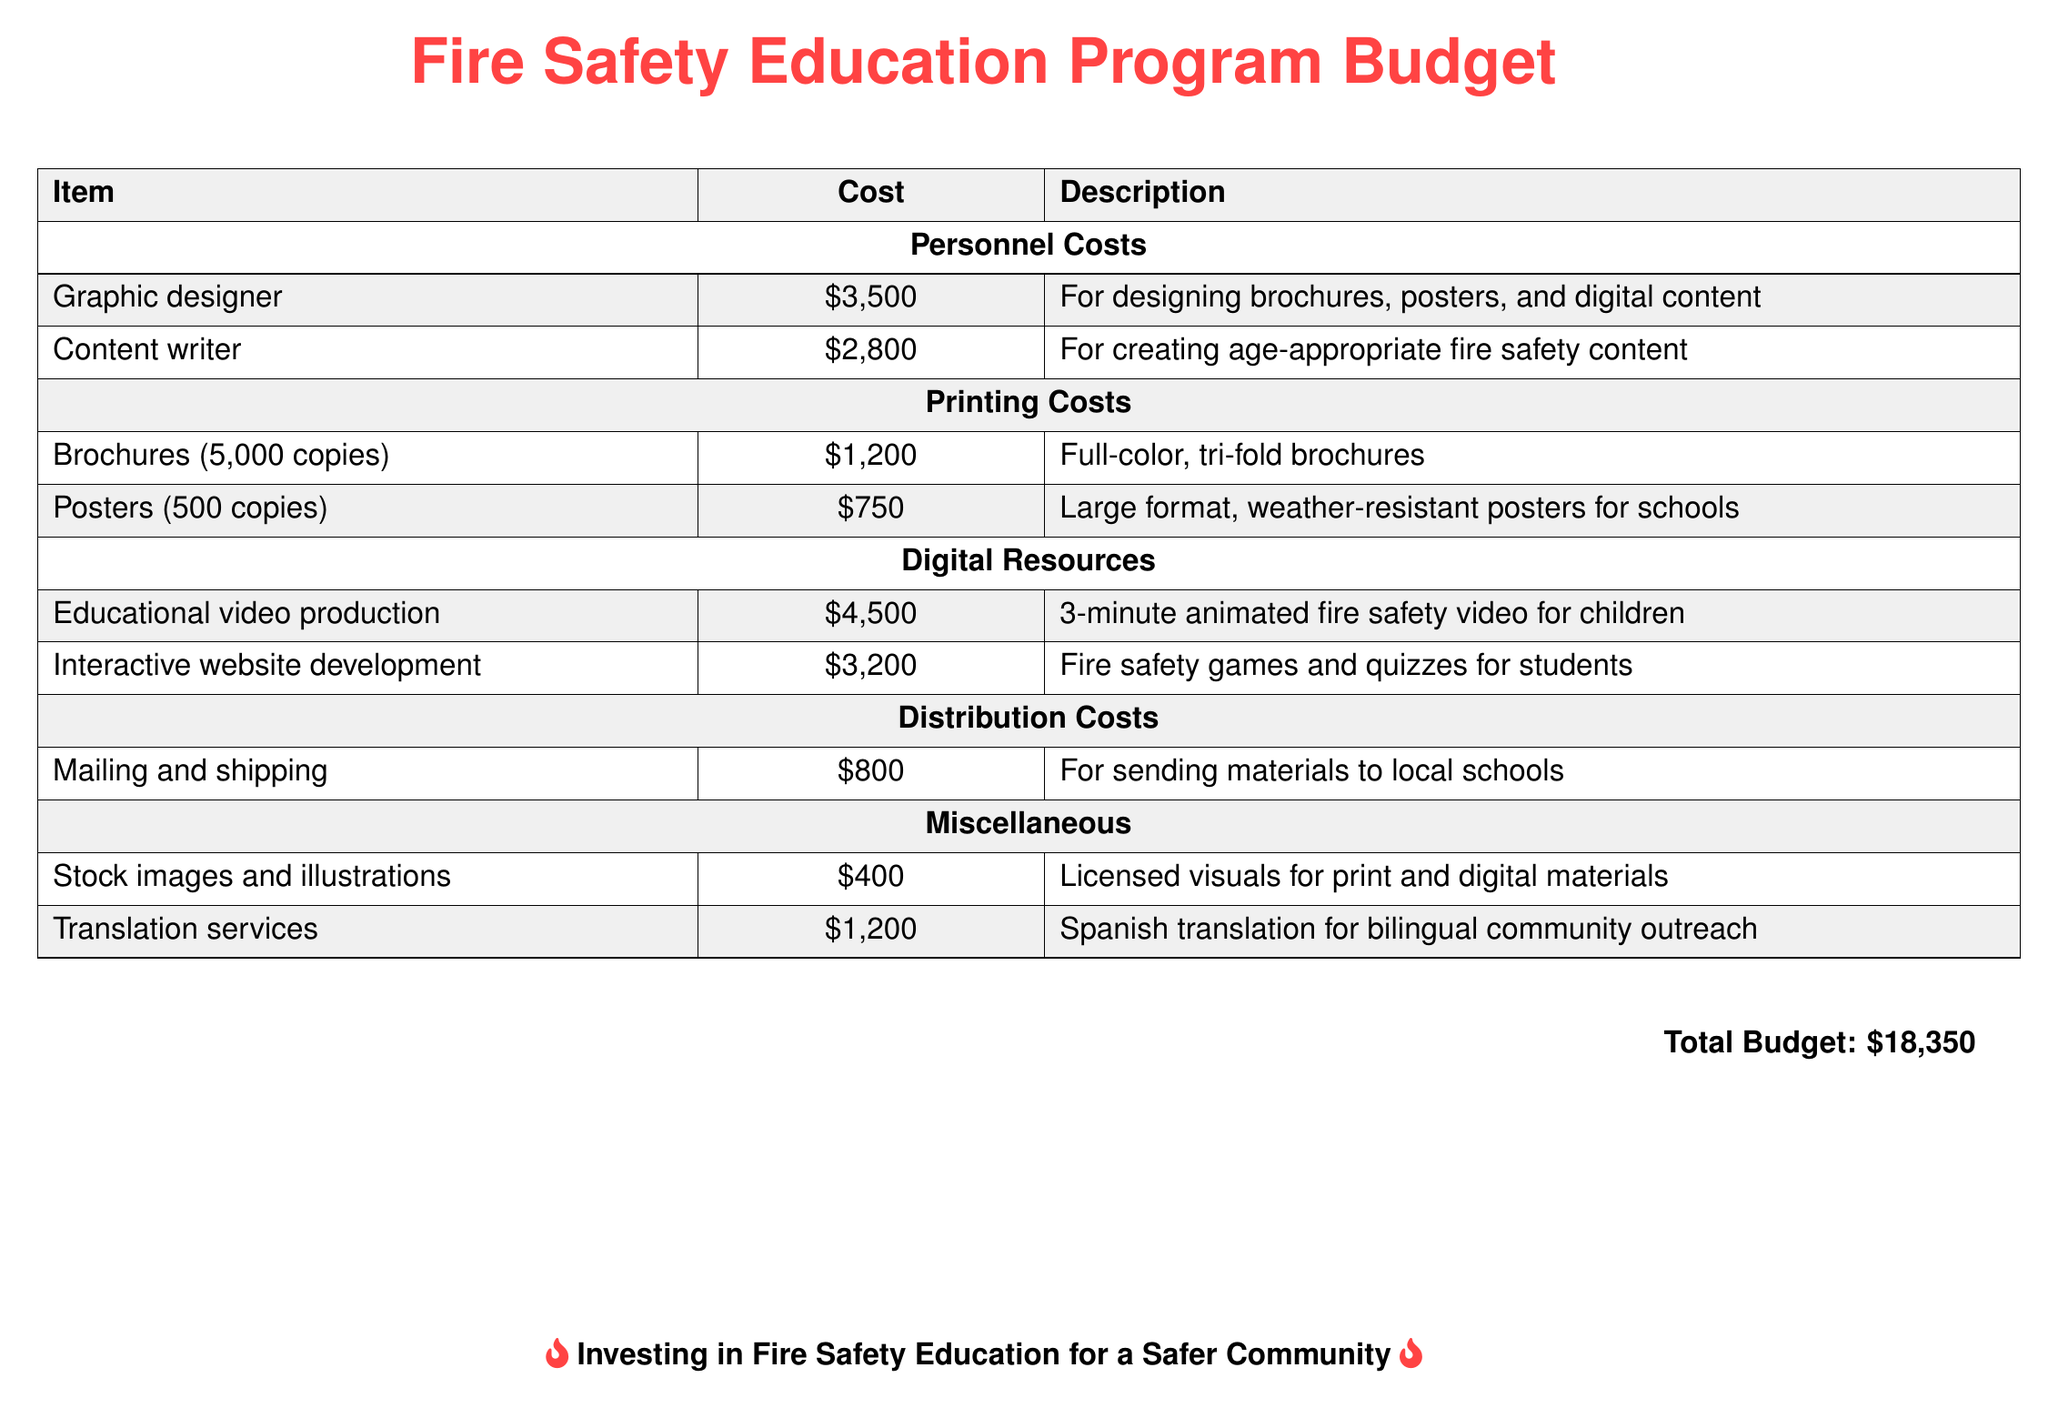What is the total budget? The total budget is found at the bottom of the document, which sums up all costs listed.
Answer: $18,350 How much is allocated for the graphic designer? The budget specifies $3,500 for the graphic designer under personnel costs.
Answer: $3,500 What is the cost for printing 5,000 brochures? The document lists $1,200 as the printing cost for 5,000 brochures.
Answer: $1,200 What item has the highest cost? The highest cost item is for educational video production, which is $4,500.
Answer: Educational video production How much is spent on translation services? The budget indicates an expense of $1,200 for translation services.
Answer: $1,200 How many copies of posters are included in the budget? The budget specifies that 500 copies of posters are included.
Answer: 500 copies What is budgeted for the development of an interactive website? The budget explicitly allocates $3,200 for interactive website development.
Answer: $3,200 Which category has the least total cost? By reviewing the listed costs, the miscellaneous category, totaling $1,600, has the least cost.
Answer: Miscellaneous What type of content does the content writer create? The description states that the content writer creates age-appropriate fire safety content.
Answer: Age-appropriate fire safety content 